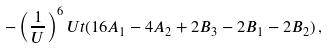Convert formula to latex. <formula><loc_0><loc_0><loc_500><loc_500>- \left ( \frac { 1 } { U } \right ) ^ { 6 } U t ( 1 6 A _ { 1 } - 4 A _ { 2 } + 2 B _ { 3 } - 2 B _ { 1 } - 2 B _ { 2 } ) \, ,</formula> 